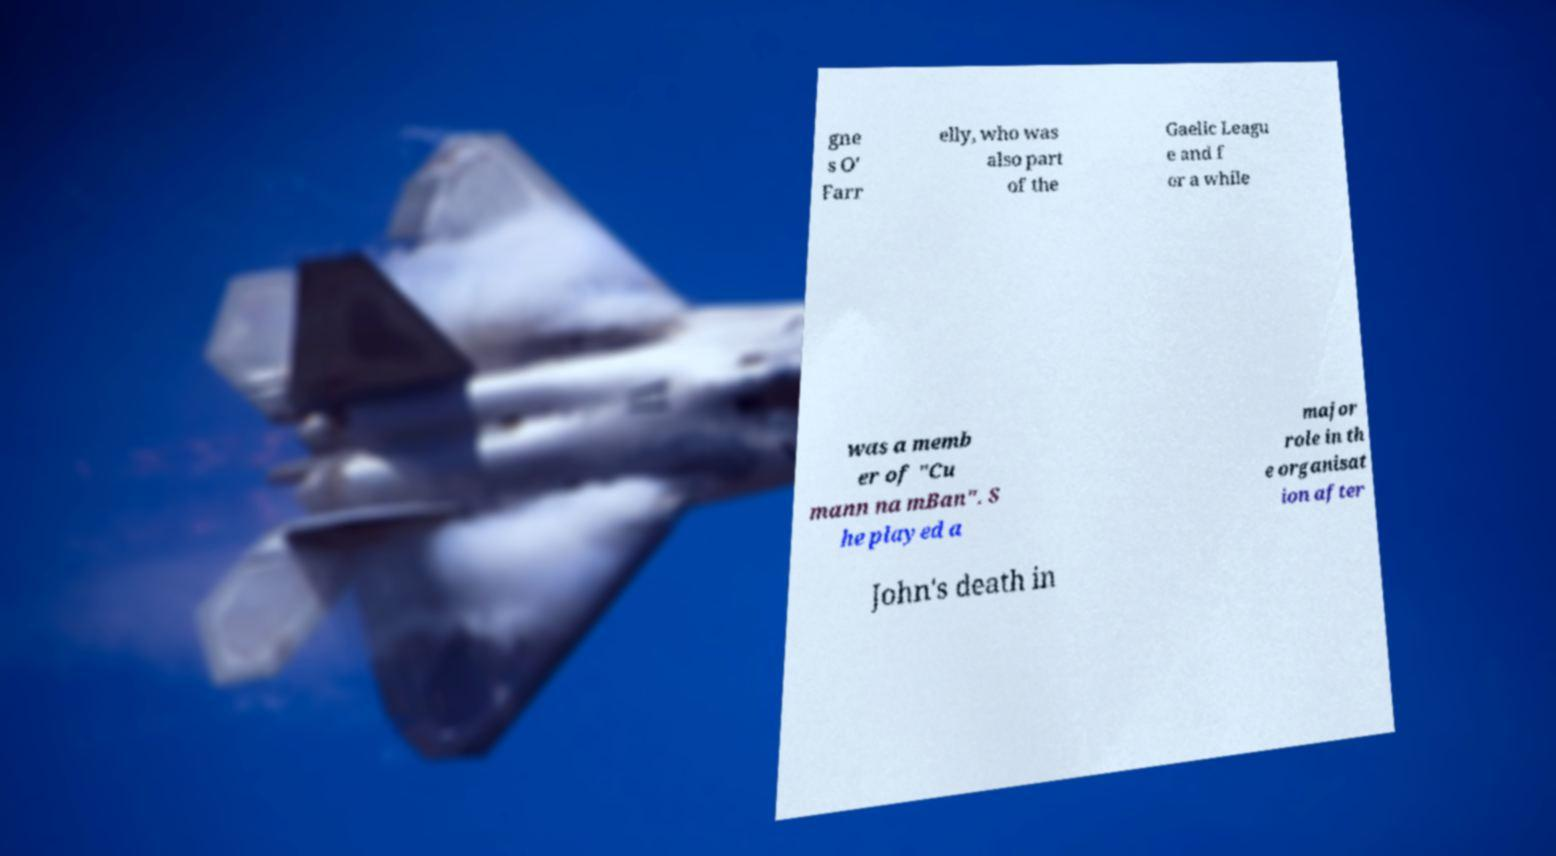There's text embedded in this image that I need extracted. Can you transcribe it verbatim? gne s O' Farr elly, who was also part of the Gaelic Leagu e and f or a while was a memb er of "Cu mann na mBan". S he played a major role in th e organisat ion after John's death in 